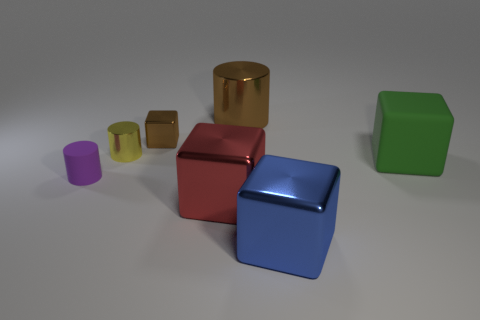Subtract all small yellow shiny cylinders. How many cylinders are left? 2 Add 1 yellow things. How many objects exist? 8 Subtract 3 cylinders. How many cylinders are left? 0 Subtract all cylinders. How many objects are left? 4 Add 4 green rubber things. How many green rubber things are left? 5 Add 1 purple matte objects. How many purple matte objects exist? 2 Subtract all green cubes. How many cubes are left? 3 Subtract 1 green cubes. How many objects are left? 6 Subtract all brown cylinders. Subtract all yellow blocks. How many cylinders are left? 2 Subtract all cyan cylinders. How many blue blocks are left? 1 